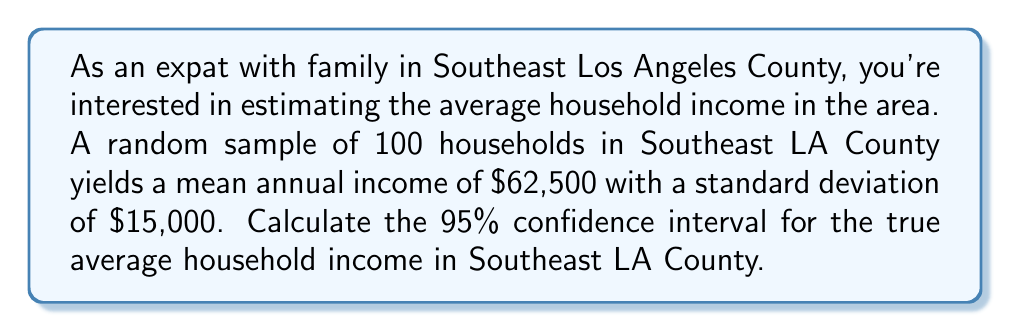Solve this math problem. To calculate the 95% confidence interval, we'll follow these steps:

1. Identify the given information:
   - Sample size (n) = 100
   - Sample mean ($\bar{x}$) = $62,500
   - Sample standard deviation (s) = $15,000
   - Confidence level = 95%

2. Determine the critical value (z-score) for a 95% confidence level:
   The z-score for a 95% confidence level is 1.96.

3. Calculate the standard error of the mean:
   $SE = \frac{s}{\sqrt{n}} = \frac{15,000}{\sqrt{100}} = \frac{15,000}{10} = 1,500$

4. Compute the margin of error:
   $ME = z \times SE = 1.96 \times 1,500 = 2,940$

5. Calculate the confidence interval:
   Lower bound: $\bar{x} - ME = 62,500 - 2,940 = 59,560$
   Upper bound: $\bar{x} + ME = 62,500 + 2,940 = 65,440$

Therefore, the 95% confidence interval for the true average household income in Southeast LA County is ($59,560, $65,440).

This means we can be 95% confident that the true population mean household income falls between $59,560 and $65,440.
Answer: ($59,560, $65,440) 